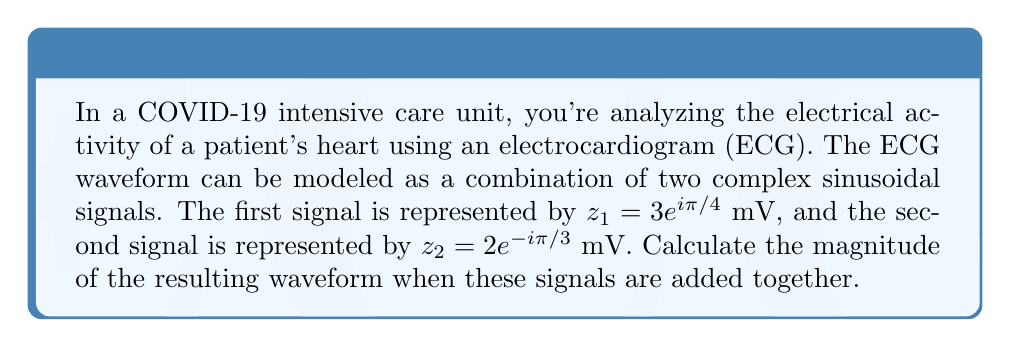What is the answer to this math problem? To solve this problem, we need to follow these steps:

1) First, let's recall that the sum of two complex numbers is obtained by adding their real and imaginary parts separately.

2) We need to convert both complex numbers from polar form to rectangular form:

   For $z_1 = 3e^{i\pi/4}$:
   $z_1 = 3(\cos(\pi/4) + i\sin(\pi/4))$
   $z_1 = 3(\frac{\sqrt{2}}{2} + i\frac{\sqrt{2}}{2})$
   $z_1 = 3\frac{\sqrt{2}}{2} + i3\frac{\sqrt{2}}{2}$

   For $z_2 = 2e^{-i\pi/3}$:
   $z_2 = 2(\cos(-\pi/3) + i\sin(-\pi/3))$
   $z_2 = 2(\frac{1}{2} - i\frac{\sqrt{3}}{2})$
   $z_2 = 1 - i\sqrt{3}$

3) Now we can add these complex numbers:

   $z = z_1 + z_2 = (3\frac{\sqrt{2}}{2} + i3\frac{\sqrt{2}}{2}) + (1 - i\sqrt{3})$
   $z = (3\frac{\sqrt{2}}{2} + 1) + i(3\frac{\sqrt{2}}{2} - \sqrt{3})$

4) To find the magnitude of this resultant complex number, we use the formula:
   $|z| = \sqrt{a^2 + b^2}$, where $a$ is the real part and $b$ is the imaginary part.

5) Therefore:
   $|z| = \sqrt{(3\frac{\sqrt{2}}{2} + 1)^2 + (3\frac{\sqrt{2}}{2} - \sqrt{3})^2}$

6) Simplifying under the square root:
   $|z| = \sqrt{(\frac{3\sqrt{2}}{2} + 1)^2 + (\frac{3\sqrt{2}}{2} - \sqrt{3})^2}$
   $|z| = \sqrt{\frac{9}{2} + 3\sqrt{2} + 1 + \frac{9}{2} - 3\sqrt{6} + 3}$
   $|z| = \sqrt{7 + 3\sqrt{2} - 3\sqrt{6}}$

This is the magnitude of the resulting waveform in millivolts (mV).
Answer: $|z| = \sqrt{7 + 3\sqrt{2} - 3\sqrt{6}}$ mV 